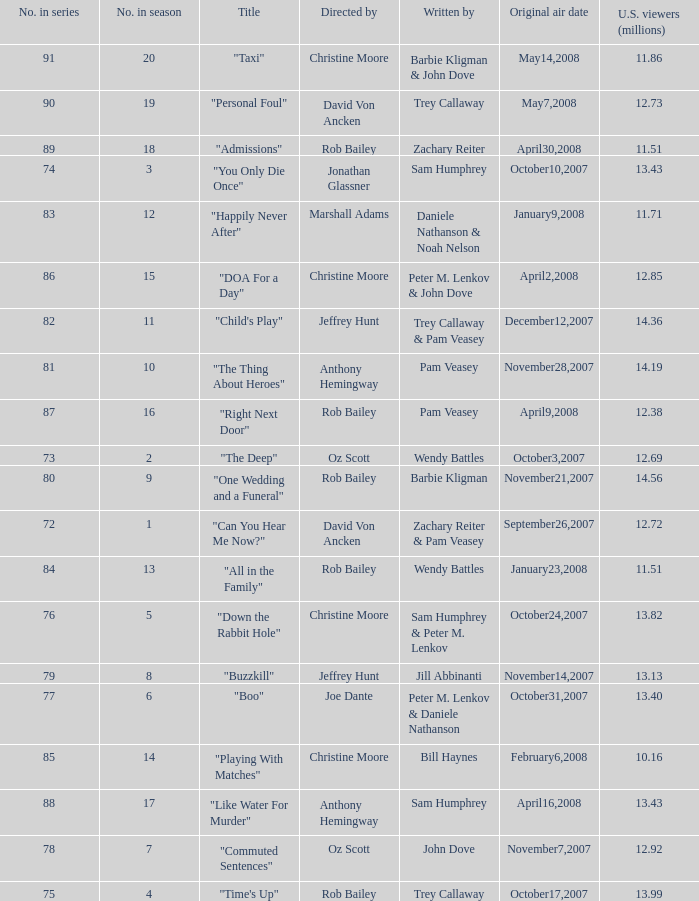How many millions of U.S. viewers watched the episode "Buzzkill"?  1.0. 